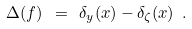<formula> <loc_0><loc_0><loc_500><loc_500>\Delta ( f ) \ = \ \delta _ { y } ( x ) - \delta _ { \zeta } ( x ) \ .</formula> 